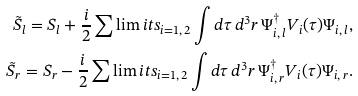<formula> <loc_0><loc_0><loc_500><loc_500>\tilde { S } _ { l } = S _ { l } + \frac { i } { 2 } \sum \lim i t s _ { i = 1 , \, 2 } \int d \tau \, d ^ { 3 } r \, \Psi _ { i , \, l } ^ { \dagger } V _ { i } ( \tau ) \Psi _ { i , \, l } , \\ \tilde { S } _ { r } = S _ { r } - \frac { i } { 2 } \sum \lim i t s _ { i = 1 , \, 2 } \int d \tau \, d ^ { 3 } r \, \Psi _ { i , \, r } ^ { \dagger } V _ { i } ( \tau ) \Psi _ { i , \, r } .</formula> 